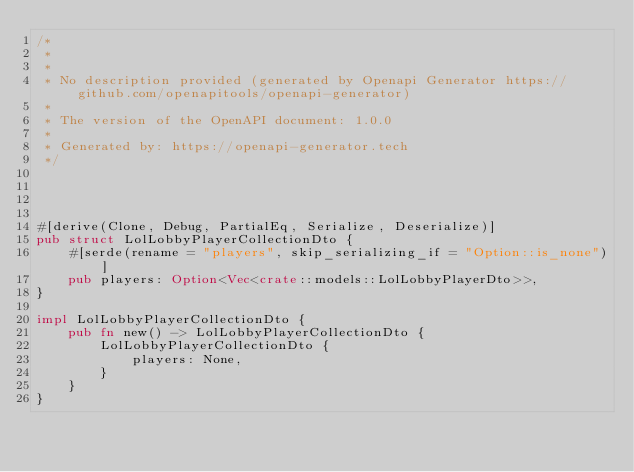<code> <loc_0><loc_0><loc_500><loc_500><_Rust_>/*
 * 
 *
 * No description provided (generated by Openapi Generator https://github.com/openapitools/openapi-generator)
 *
 * The version of the OpenAPI document: 1.0.0
 * 
 * Generated by: https://openapi-generator.tech
 */




#[derive(Clone, Debug, PartialEq, Serialize, Deserialize)]
pub struct LolLobbyPlayerCollectionDto {
    #[serde(rename = "players", skip_serializing_if = "Option::is_none")]
    pub players: Option<Vec<crate::models::LolLobbyPlayerDto>>,
}

impl LolLobbyPlayerCollectionDto {
    pub fn new() -> LolLobbyPlayerCollectionDto {
        LolLobbyPlayerCollectionDto {
            players: None,
        }
    }
}


</code> 